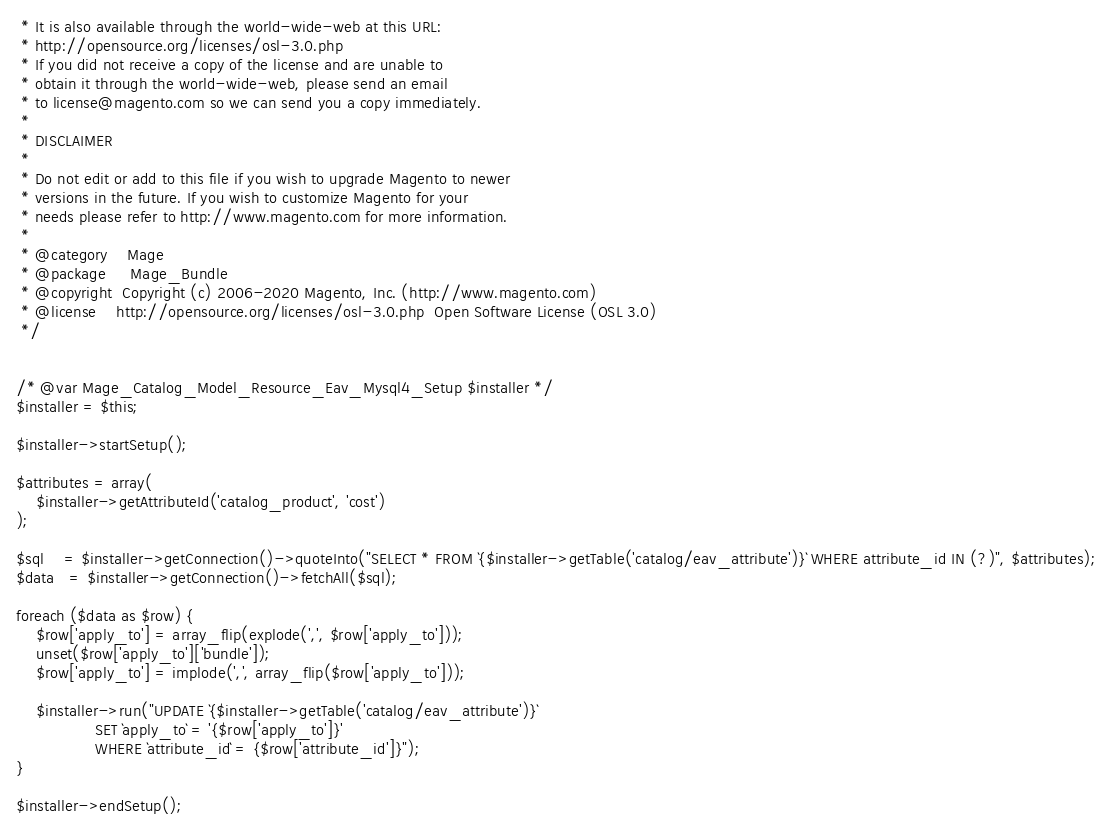<code> <loc_0><loc_0><loc_500><loc_500><_PHP_> * It is also available through the world-wide-web at this URL:
 * http://opensource.org/licenses/osl-3.0.php
 * If you did not receive a copy of the license and are unable to
 * obtain it through the world-wide-web, please send an email
 * to license@magento.com so we can send you a copy immediately.
 *
 * DISCLAIMER
 *
 * Do not edit or add to this file if you wish to upgrade Magento to newer
 * versions in the future. If you wish to customize Magento for your
 * needs please refer to http://www.magento.com for more information.
 *
 * @category    Mage
 * @package     Mage_Bundle
 * @copyright  Copyright (c) 2006-2020 Magento, Inc. (http://www.magento.com)
 * @license    http://opensource.org/licenses/osl-3.0.php  Open Software License (OSL 3.0)
 */


/* @var Mage_Catalog_Model_Resource_Eav_Mysql4_Setup $installer */
$installer = $this;

$installer->startSetup();

$attributes = array(
    $installer->getAttributeId('catalog_product', 'cost')
);

$sql    = $installer->getConnection()->quoteInto("SELECT * FROM `{$installer->getTable('catalog/eav_attribute')}` WHERE attribute_id IN (?)", $attributes);
$data   = $installer->getConnection()->fetchAll($sql);

foreach ($data as $row) {
    $row['apply_to'] = array_flip(explode(',', $row['apply_to']));
    unset($row['apply_to']['bundle']);
    $row['apply_to'] = implode(',', array_flip($row['apply_to']));

    $installer->run("UPDATE `{$installer->getTable('catalog/eav_attribute')}`
                SET `apply_to` = '{$row['apply_to']}'
                WHERE `attribute_id` = {$row['attribute_id']}");
}

$installer->endSetup();
</code> 